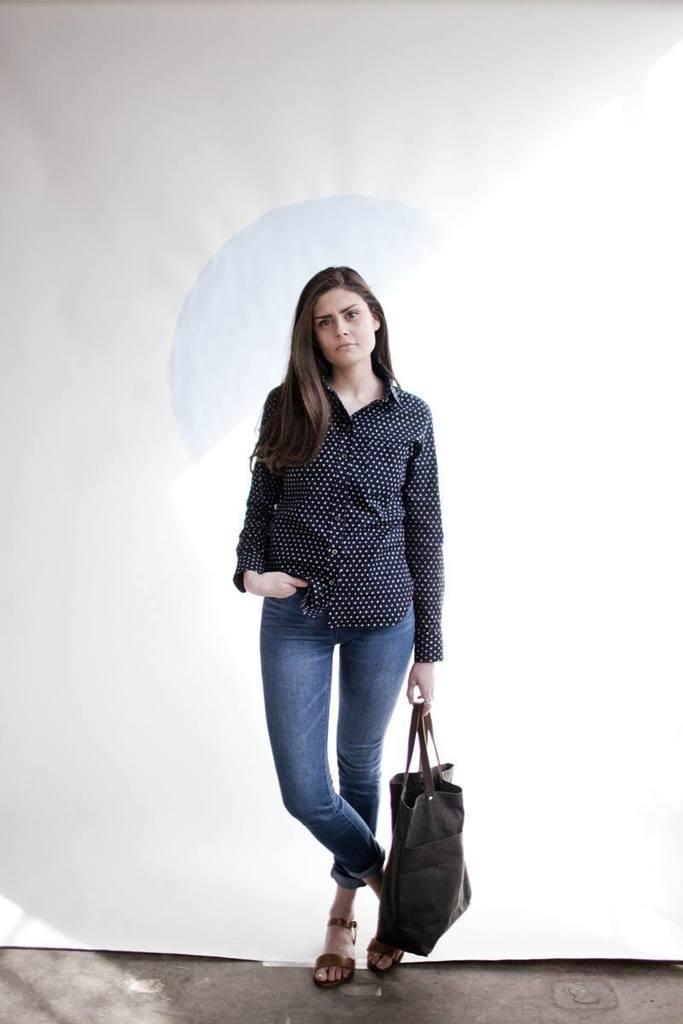Describe this image in one or two sentences. There is a women with fair white skin tone, with black and white shirt, blue jeans, she is standing and holding a bag. There is a white background at the back. 